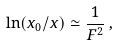<formula> <loc_0><loc_0><loc_500><loc_500>\ln ( x _ { 0 } / x ) \simeq \frac { 1 } { F ^ { 2 } } \, ,</formula> 